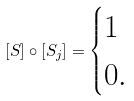Convert formula to latex. <formula><loc_0><loc_0><loc_500><loc_500>[ S ] \circ [ S _ { j } ] = \begin{cases} 1 \\ 0 . \end{cases}</formula> 